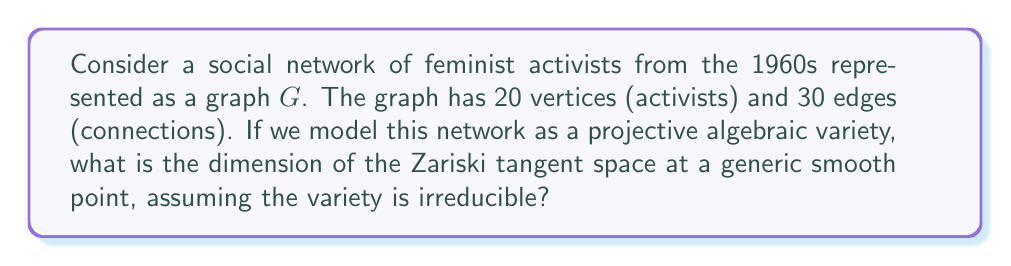Could you help me with this problem? Let's approach this step-by-step:

1) In algebraic geometry, a graph can be represented as an algebraic variety. For a graph with $n$ vertices and $e$ edges, we can consider it as a point in the affine space $\mathbb{A}^{\binom{n}{2}}$.

2) In our case, $n = 20$ and $e = 30$. The dimension of the ambient space is:

   $$\binom{20}{2} = \frac{20 \cdot 19}{2} = 190$$

3) The graph variety $X_G$ is defined by equations that force certain coordinates (non-edges) to be zero. The number of these equations is:

   $$\binom{20}{2} - 30 = 190 - 30 = 160$$

4) For a generic smooth point on an irreducible variety, the dimension of the Zariski tangent space is equal to the dimension of the variety itself.

5) By the theorem on the dimension of fibers, we have:

   $$\dim X_G = \dim \mathbb{A}^{\binom{n}{2}} - \text{number of independent equations}$$

6) In the best case scenario (when all equations are independent), we have:

   $$\dim X_G = 190 - 160 = 30$$

7) Therefore, the dimension of the Zariski tangent space at a generic smooth point is 30.
Answer: 30 